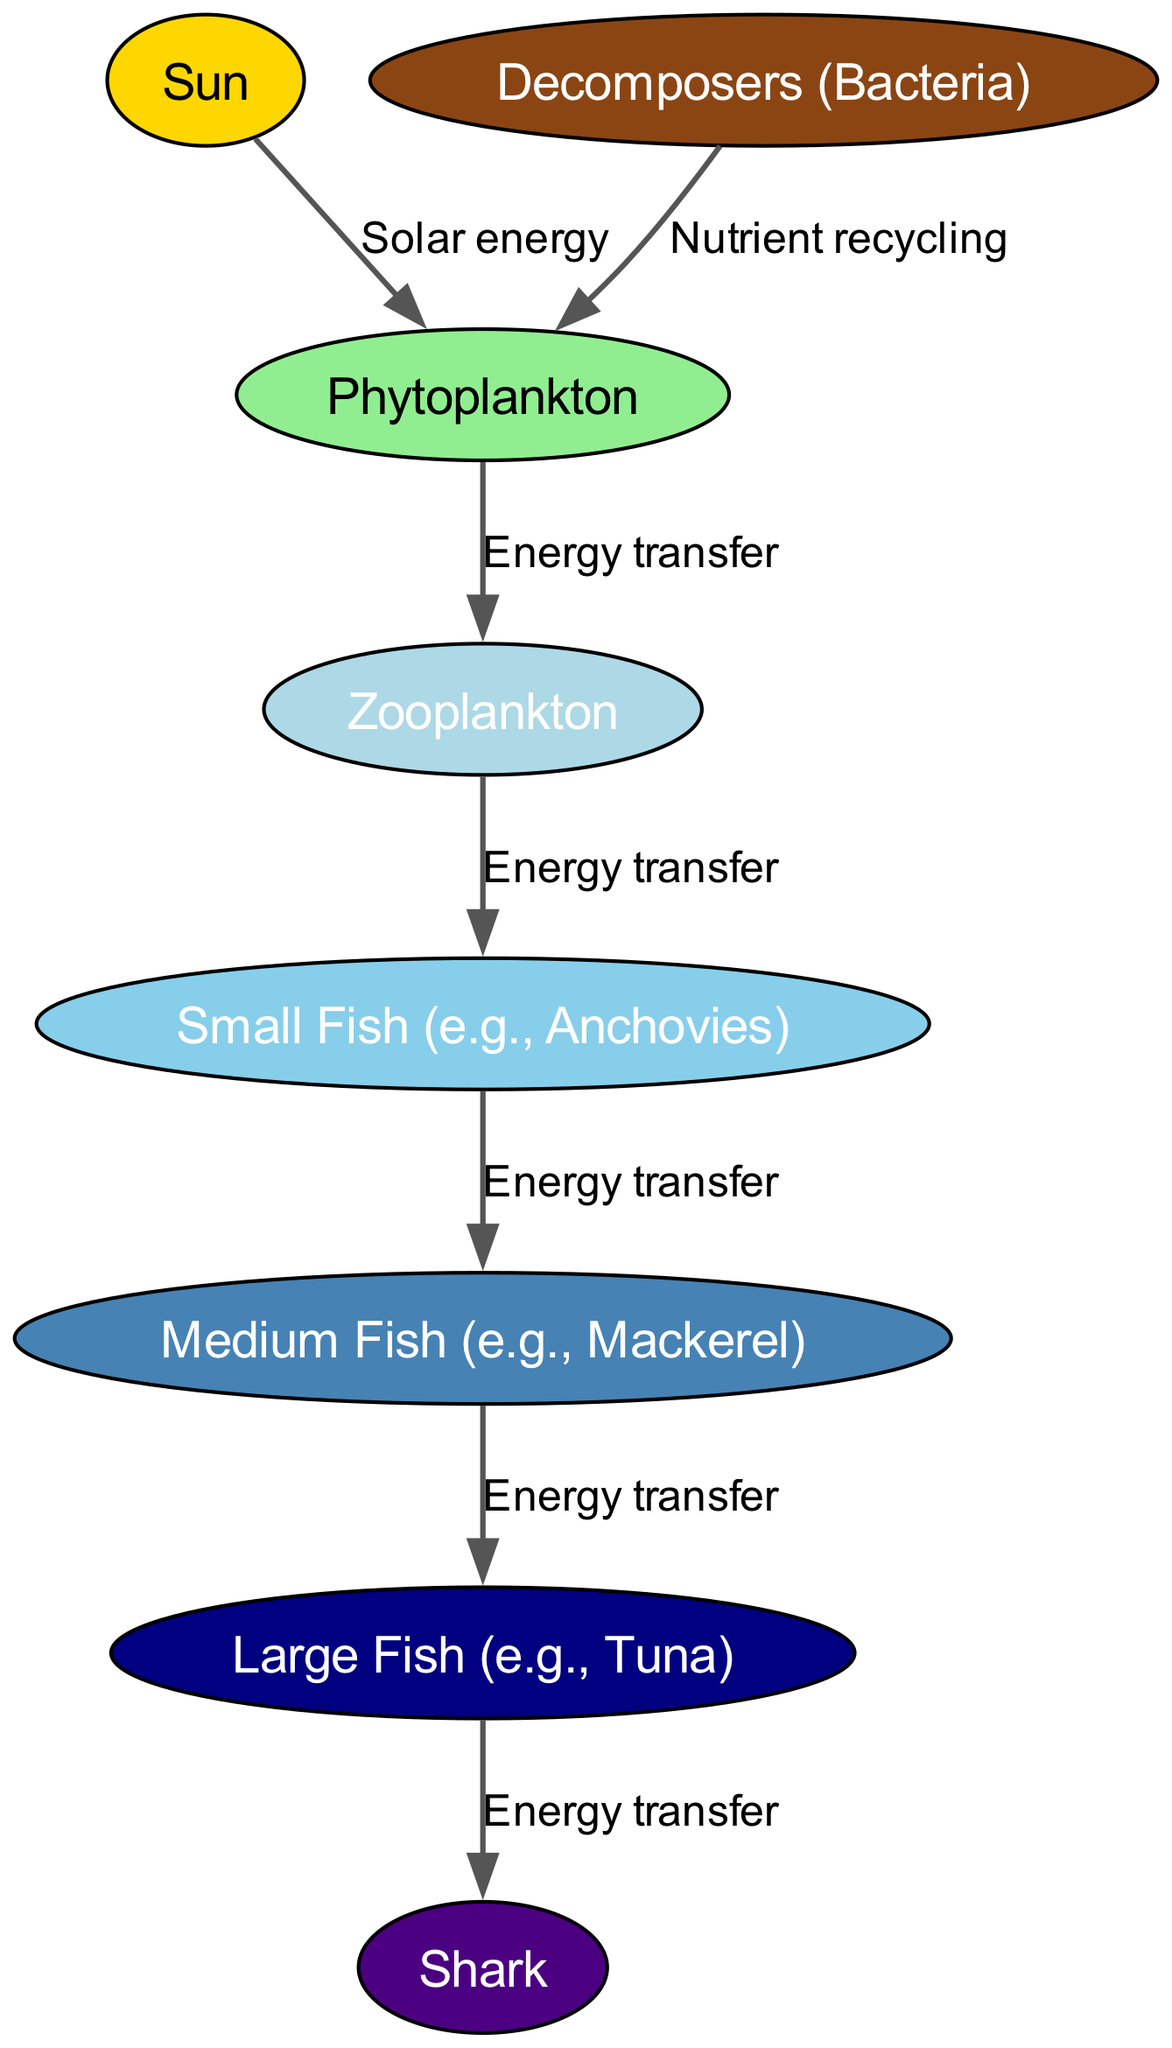What is the source of energy in this marine food web? The diagram shows the sun as the primary source of energy, which is connected to the phytoplankton node with an arrow labeled "Solar energy." This indicates that the sun provides solar energy that initiates the energy flow in the ecosystem.
Answer: Sun How many levels are there in the food web? The food web consists of six levels, starting with the sun at the top and ending with the shark at the bottom, along with the decomposers and various fish types in between.
Answer: 6 Which organism directly consumes phytoplankton? According to the diagram, zooplankton is the organism that directly consumes phytoplankton, as indicated by the arrow labeled "Energy transfer" connecting these two nodes.
Answer: Zooplankton What role do decomposers play in this ecosystem? Decomposers are illustrated in the diagram as recycling nutrients back to the phytoplankton, as shown by the arrow labeled "Nutrient recycling." This indicates that they play a critical role in nutrient cycling within the marine ecosystem.
Answer: Nutrient recycling What type of fish is shown as a predator of small fish? In the food web, medium fish are depicted as predators of small fish, as indicated by the arrow labeled "Energy transfer" going from small fish to medium fish.
Answer: Medium Fish How does energy flow from large fish to sharks? The diagram indicates that energy flows from large fish to sharks through the arrow labeled "Energy transfer." This shows that sharks are higher up in the food web and consume large fish for energy.
Answer: Energy transfer How many direct connections does phytoplankton have in the food web? The phytoplankton node has two direct connections: one to zooplankton, and one from decomposers indicating nutrient recycling back to it. Therefore, the total number of direct connections is two.
Answer: 2 Who is at the top of the food chain in this diagram? The shark is depicted at the top of the food chain as the last node in the energy transfer sequence, receiving energy from large fish, indicating it is a top predator in this marine ecosystem.
Answer: Shark 